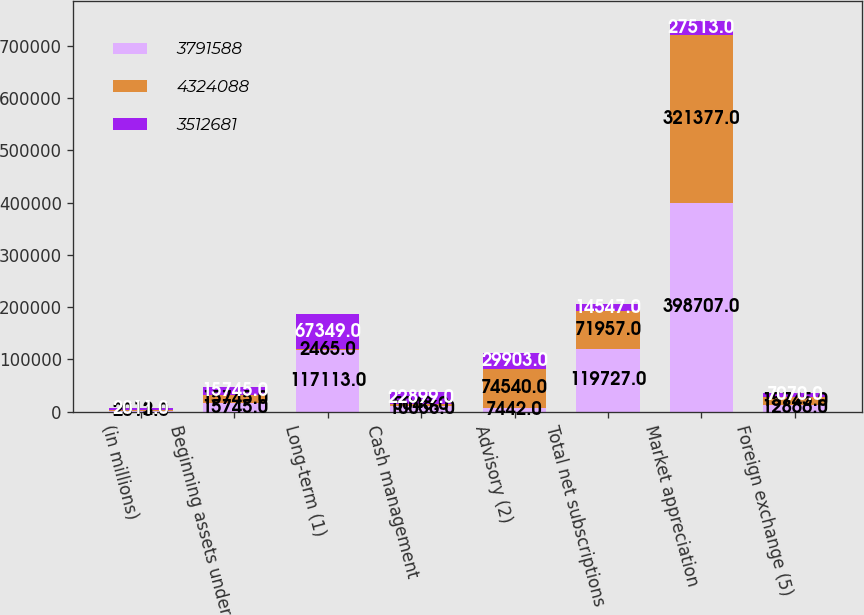<chart> <loc_0><loc_0><loc_500><loc_500><stacked_bar_chart><ecel><fcel>(in millions)<fcel>Beginning assets under<fcel>Long-term (1)<fcel>Cash management<fcel>Advisory (2)<fcel>Total net subscriptions<fcel>Market appreciation<fcel>Foreign exchange (5)<nl><fcel>3.79159e+06<fcel>2013<fcel>15745<fcel>117113<fcel>10056<fcel>7442<fcel>119727<fcel>398707<fcel>12866<nl><fcel>4.32409e+06<fcel>2012<fcel>15745<fcel>2465<fcel>5048<fcel>74540<fcel>71957<fcel>321377<fcel>15745<nl><fcel>3.51268e+06<fcel>2011<fcel>15745<fcel>67349<fcel>22899<fcel>29903<fcel>14547<fcel>27513<fcel>7070<nl></chart> 